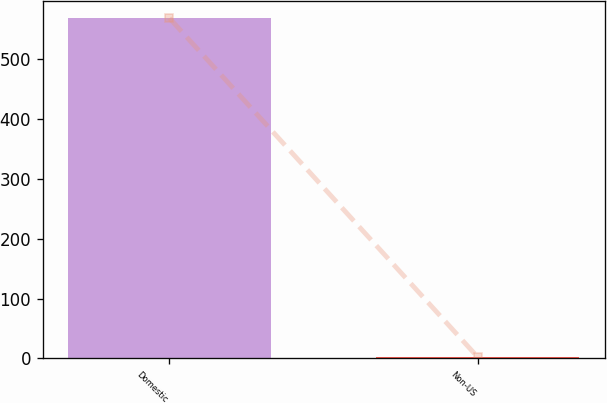Convert chart to OTSL. <chart><loc_0><loc_0><loc_500><loc_500><bar_chart><fcel>Domestic<fcel>Non-US<nl><fcel>569<fcel>2.3<nl></chart> 